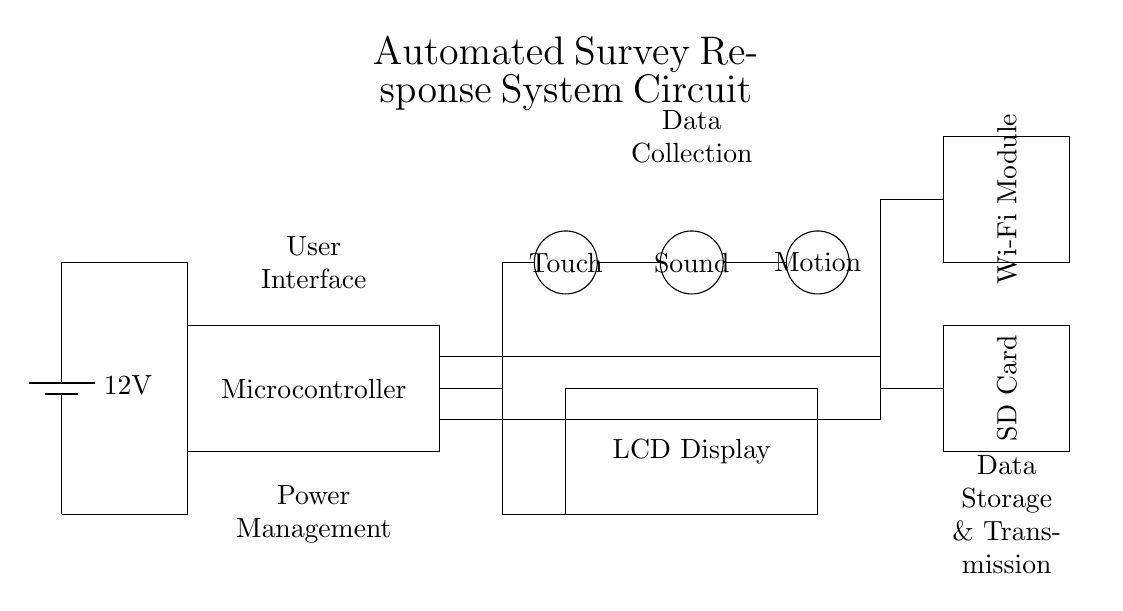What is the main power voltage of this circuit? The main power supply in the circuit is labeled as a battery with a voltage of 12 volts. This information is directly indicated on the battery icon in the diagram.
Answer: 12 volts What components are used for data collection? The circuit includes three sensors for data collection: a touch sensor, a sound sensor, and a motion sensor. These sensors are represented by circles labeled appropriately in the diagram.
Answer: Touch, Sound, Motion What is the purpose of the displayed device? The LCD Display serves as the user interface in this system, indicated by the rectangle labeled "LCD Display." It is used to present information to the user.
Answer: User interface How do data storage and transmission occur in this circuit? The circuit includes an SD card for data storage and a Wi-Fi module for data transmission. The SD card is represented in a rectangle, while the Wi-Fi module is also shown in a rectangle, highlighting their roles.
Answer: SD Card, Wi-Fi Module What component connects the power supply to the microcontroller? The connection from the battery to the microcontroller is made with direct wiring indicated by lines in the diagram. The lines clearly show the path of electrical flow delivering power to the microcontroller.
Answer: Wiring Why is the wireless module significant in this circuit? The wireless module is essential for transmitting collected data externally, allowing remote data access and analysis. This capability is indicated through its presence and label in the diagram.
Answer: Data transmission 